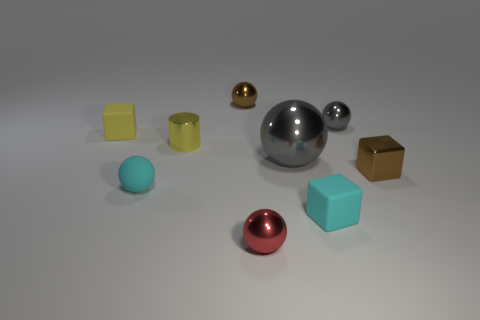There is a small shiny thing that is in front of the small yellow shiny thing and on the left side of the small brown metal block; what is its shape? sphere 